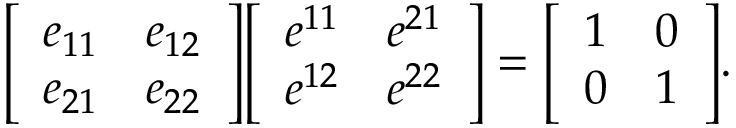Convert formula to latex. <formula><loc_0><loc_0><loc_500><loc_500>{ \left [ \begin{array} { l l } { e _ { 1 1 } } & { e _ { 1 2 } } \\ { e _ { 2 1 } } & { e _ { 2 2 } } \end{array} \right ] } { \left [ \begin{array} { l l } { e ^ { 1 1 } } & { e ^ { 2 1 } } \\ { e ^ { 1 2 } } & { e ^ { 2 2 } } \end{array} \right ] } = { \left [ \begin{array} { l l } { 1 } & { 0 } \\ { 0 } & { 1 } \end{array} \right ] } .</formula> 